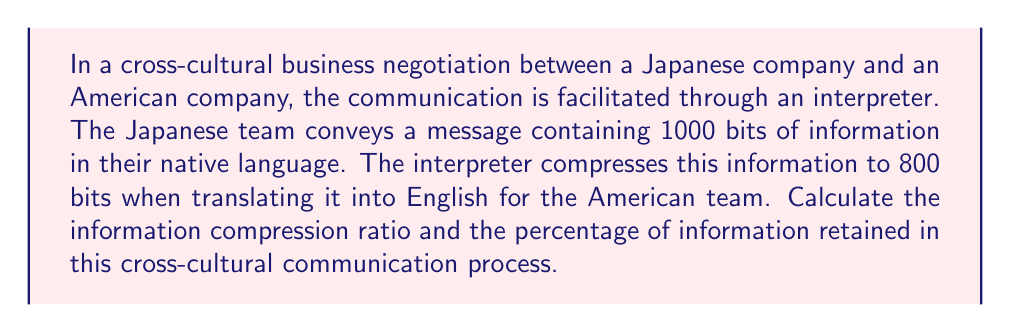Can you answer this question? To solve this problem, we need to understand the concept of information compression ratio and how to calculate it. Let's break it down step-by-step:

1. Information compression ratio:
   The compression ratio is defined as the ratio of the original size to the compressed size.

   $$ \text{Compression Ratio} = \frac{\text{Original Size}}{\text{Compressed Size}} $$

2. Given information:
   - Original message (in Japanese): 1000 bits
   - Compressed message (in English): 800 bits

3. Calculate the compression ratio:
   $$ \text{Compression Ratio} = \frac{1000 \text{ bits}}{800 \text{ bits}} = 1.25 $$

4. To calculate the percentage of information retained:
   $$ \text{Information Retained (\%)} = \frac{\text{Compressed Size}}{\text{Original Size}} \times 100\% $$

5. Calculate the percentage of information retained:
   $$ \text{Information Retained (\%)} = \frac{800 \text{ bits}}{1000 \text{ bits}} \times 100\% = 80\% $$

This analysis shows that in the process of cross-cultural communication and translation, some information is inevitably lost or compressed. The compression ratio of 1.25 indicates that for every 1.25 bits of original information, 1 bit is retained after translation. The 80% retention rate suggests that while most of the information is preserved, there is still a significant loss in the nuances and details of the original message.
Answer: The information compression ratio is 1.25, and the percentage of information retained is 80%. 